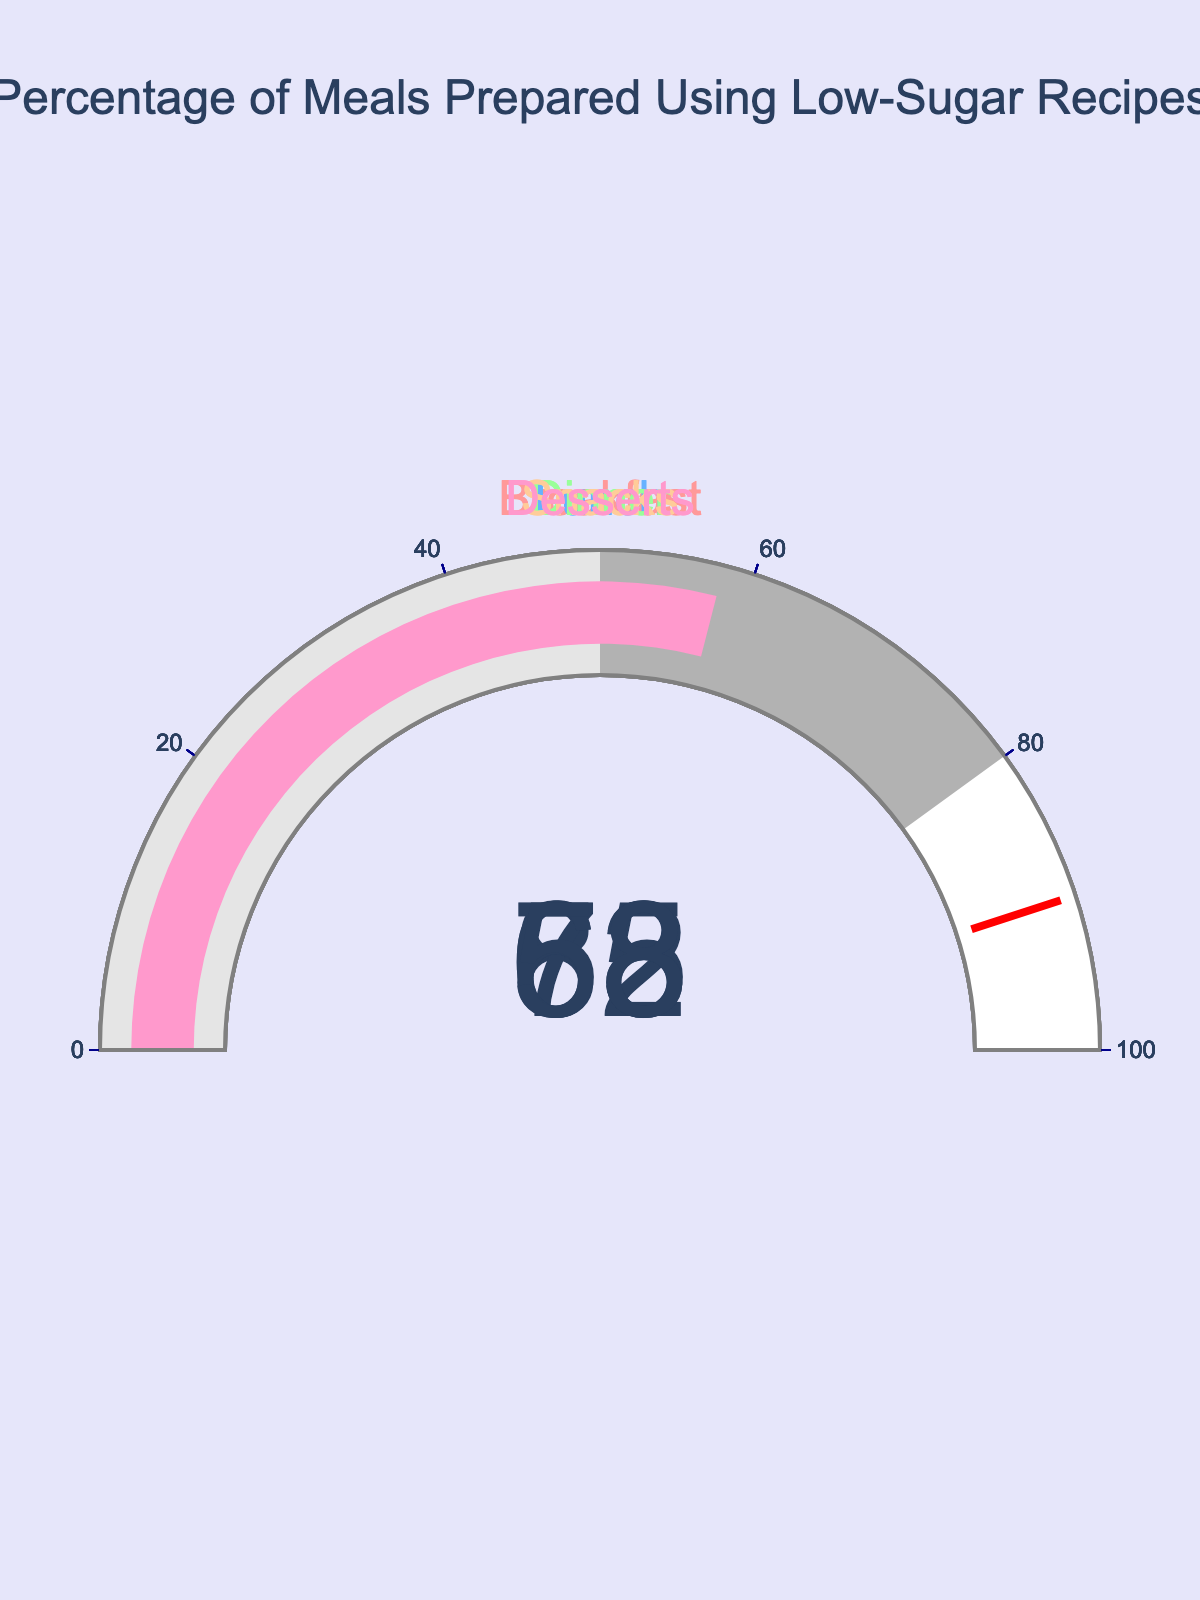What's the title of the figure? The title of the figure is displayed at the top, centered and in larger font size compared to other text elements.
Answer: Percentage of Meals Prepared Using Low-Sugar Recipes How many meal types are shown in the figure? By counting the number of gauges in the figure, you can determine the number of meal types displayed.
Answer: 5 Which meal type has the highest percentage of meals prepared using low-sugar recipes? Locate the gauge with the highest value on its display to identify the meal type.
Answer: Breakfast Is the percentage of lunches prepared using low-sugar recipes higher than snacks? Compare the percentage values displayed on the gauges for Lunch and Snacks to determine which is higher.
Answer: Yes What is the average percentage of meals prepared using low-sugar recipes for all meal types? Add up the percentages of all meal types and divide by the number of meal types: (85 + 72 + 68 + 63 + 58) / 5.
Answer: 69.2 Which meal type falls below 60% in low-sugar recipe usage? Identify the gauge with a percentage value below 60 to determine the corresponding meal type.
Answer: Desserts What is the difference in percentage between Breakfast and Dinner? Subtract the percentage value of Dinner from the percentage value of Breakfast: 85 - 68.
Answer: 17 Are more than half of the snacks prepared using low-sugar recipes? Check if the percentage value for Snacks is greater than 50.
Answer: Yes What percentage of Desserts are prepared using low-sugar recipes? Look at the gauge associated with Desserts to find its percentage value.
Answer: 58 Is the percentage of meals prepared using low-sugar recipes for Lunch closer to Breakfast or Dinner? Calculate the difference between Lunch and both Breakfast and Dinner, then compare: abs(72-85) and abs(72-68).
Answer: Dinner 